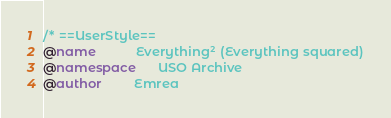Convert code to text. <code><loc_0><loc_0><loc_500><loc_500><_CSS_>/* ==UserStyle==
@name           Everything² (Everything squared)
@namespace      USO Archive
@author         Emrea</code> 